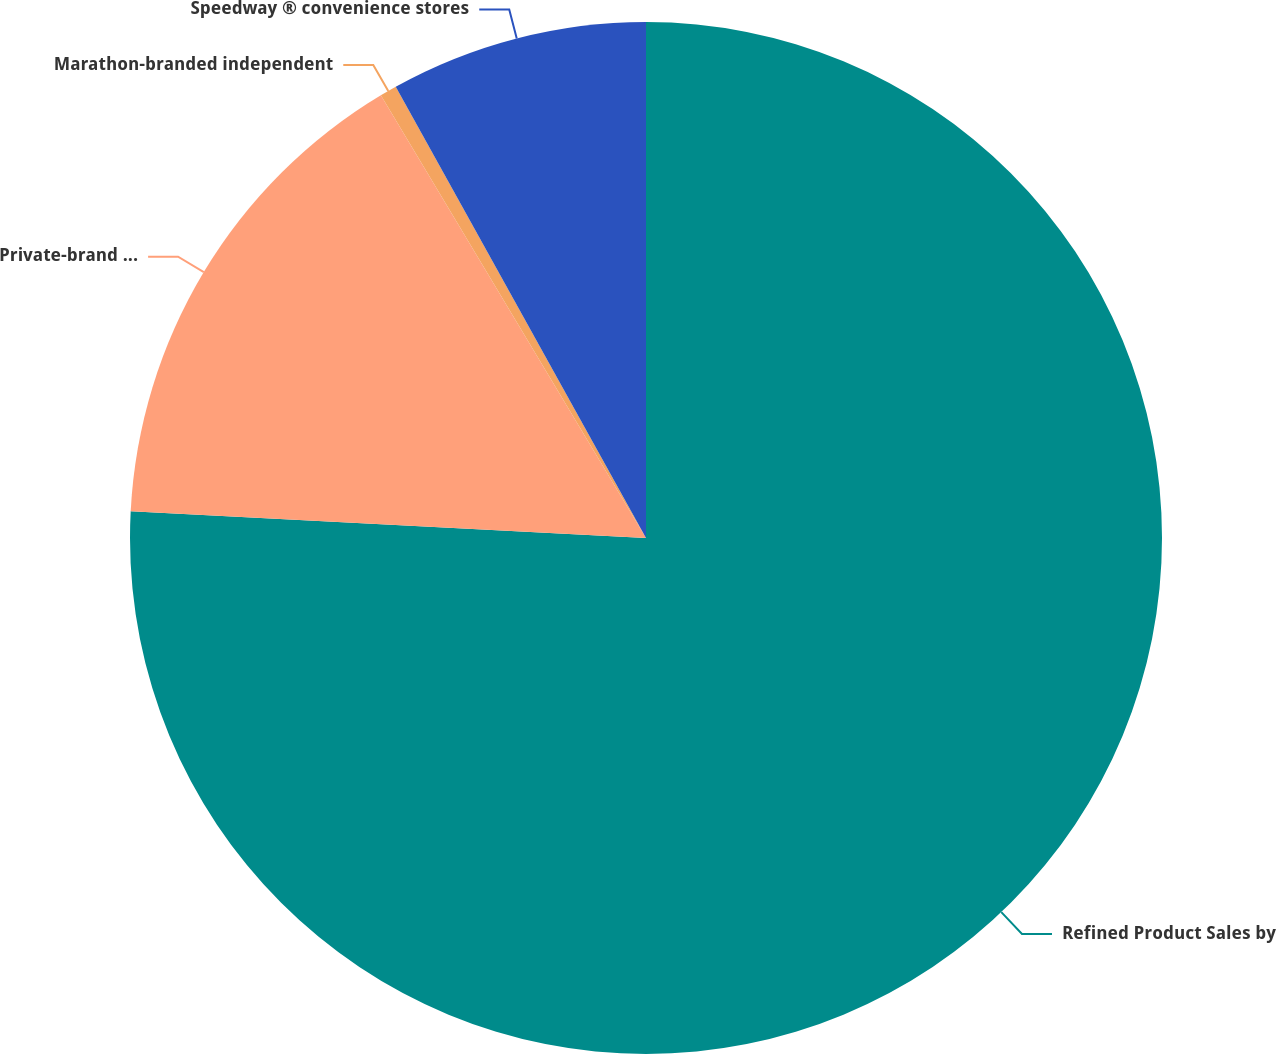Convert chart to OTSL. <chart><loc_0><loc_0><loc_500><loc_500><pie_chart><fcel>Refined Product Sales by<fcel>Private-brand marketers<fcel>Marathon-branded independent<fcel>Speedway ® convenience stores<nl><fcel>75.83%<fcel>15.59%<fcel>0.53%<fcel>8.06%<nl></chart> 